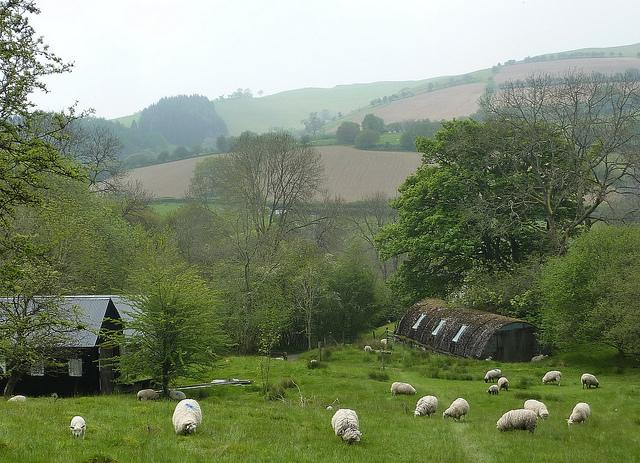What building material is the longhouse next to the sheep? Please explain your reasoning. sticks. A log cabin style structure with a thatch roof is near sheep grazing. 